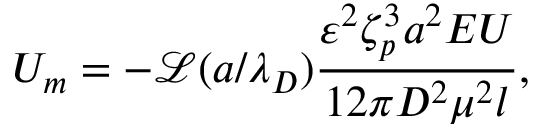Convert formula to latex. <formula><loc_0><loc_0><loc_500><loc_500>U _ { m } = - \mathcal { L } ( a / \lambda _ { D } ) \frac { \varepsilon ^ { 2 } \zeta _ { p } ^ { 3 } a ^ { 2 } E U } { 1 2 \pi D ^ { 2 } \mu ^ { 2 } l } ,</formula> 